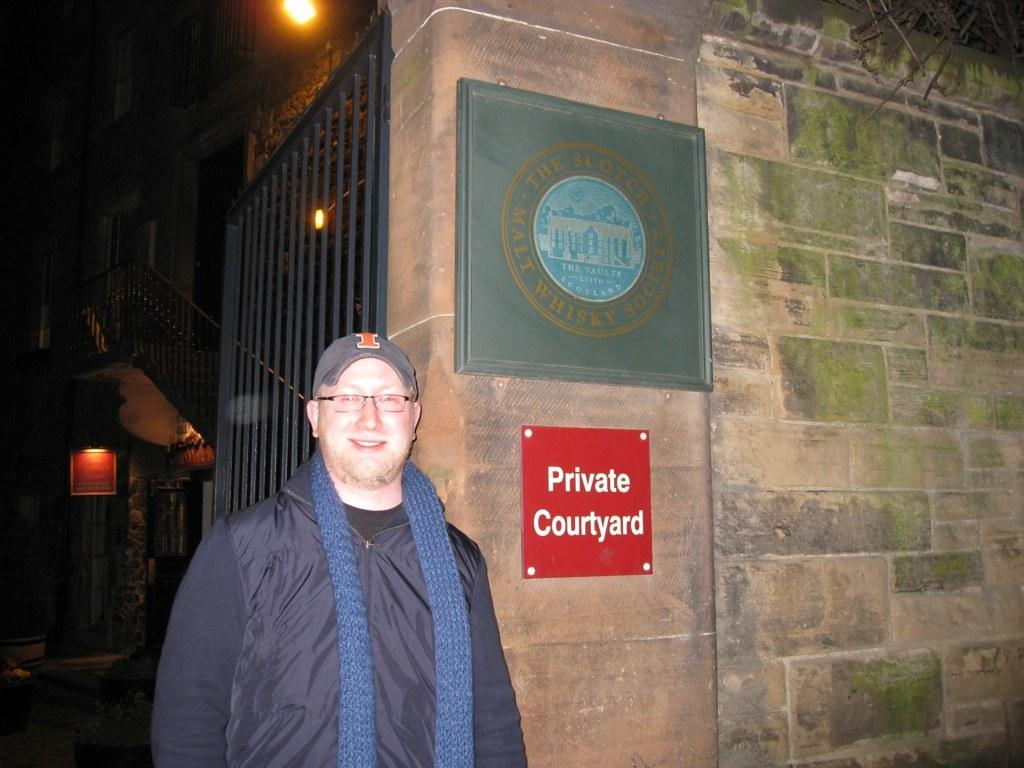What is the main subject of the image? The main subject of the image is a man standing. Can you describe the man's appearance? The man is wearing clothes, spectacles, and a cap. He is also smiling. What other objects are present in the image? There is a scarf, a board, a fence, and a light in the image. What type of food is being served on the canvas in the image? There is no canvas or food present in the image. What color is the silver object in the image? There is no silver object present in the image. 